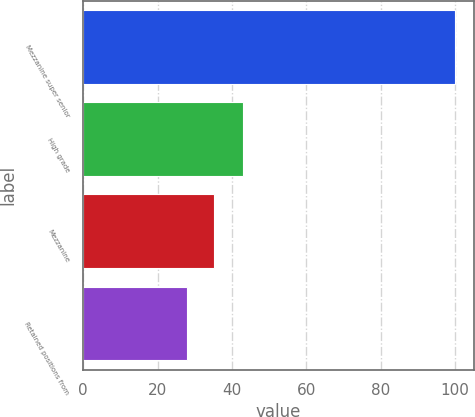Convert chart. <chart><loc_0><loc_0><loc_500><loc_500><bar_chart><fcel>Mezzanine super senior<fcel>High grade<fcel>Mezzanine<fcel>Retained positions from<nl><fcel>100<fcel>43<fcel>35.2<fcel>28<nl></chart> 